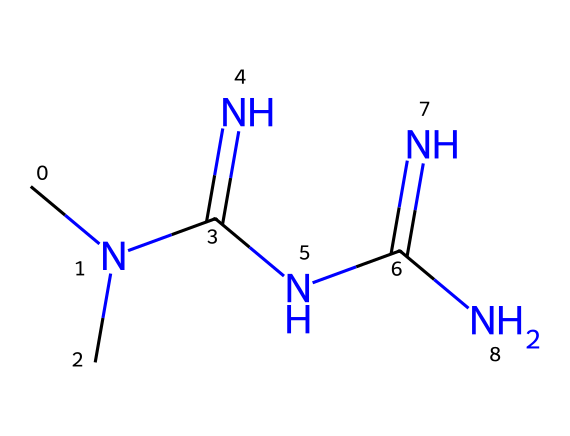How many nitrogen atoms are present in the structure? The chemical structure features multiple nitrogen atoms, which are denoted by the "N" symbols in the SMILES representation. Counting them reveals that there are five nitrogen atoms.
Answer: five What functional groups are present in this compound? The SMILES representation shows the presence of amine groups, indicated by the nitrogen atoms connected to carbon. The presence of "N(C)" suggests secondary amines, while multiple "NC" connections signify primary amines.
Answer: amine groups What is the molecular formula of metformin? To derive the molecular formula from the SMILES, I identify the constituent atoms: 1 carbon relates to the "C", 5 nitrogens from "N", and 11 hydrogens implied through connections. This consolidates into C4H11N5.
Answer: C4H11N5 Which part of the molecule indicates its role in regulating blood sugar? The multiple nitrogen atoms and their arrangement suggest a role in mimicking certain biological activities related to insulin response and glucose metabolism. The amine functionality is key in this function.
Answer: nitrogen atoms How many total carbon atoms are in the structure? By analyzing the SMILES notation, I can distinguish that there are four distinct carbon atoms in the structure, represented by "C" symbols in the sequence.
Answer: four 